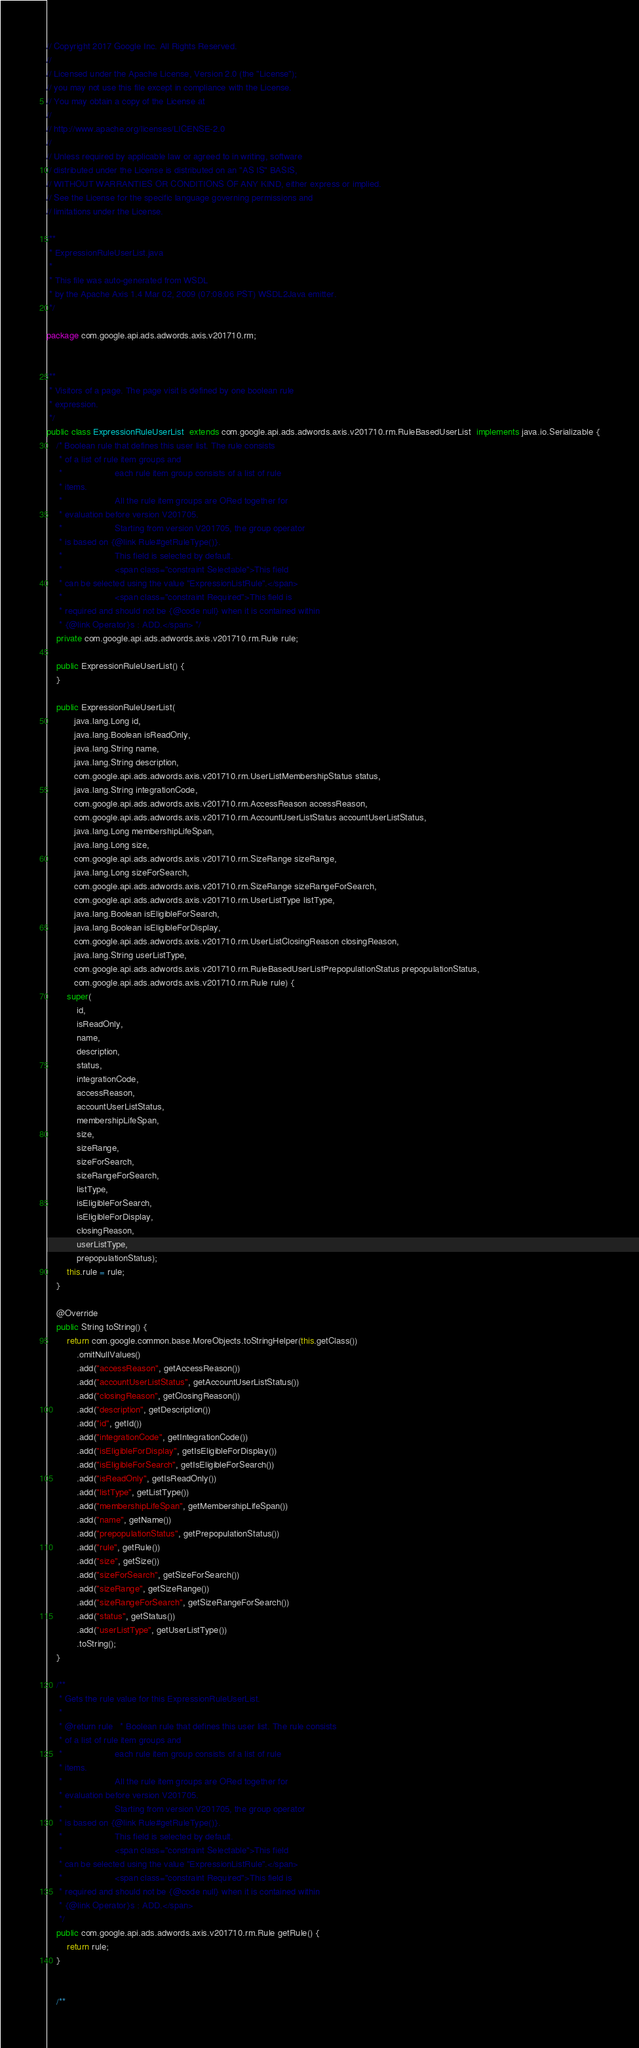<code> <loc_0><loc_0><loc_500><loc_500><_Java_>// Copyright 2017 Google Inc. All Rights Reserved.
//
// Licensed under the Apache License, Version 2.0 (the "License");
// you may not use this file except in compliance with the License.
// You may obtain a copy of the License at
//
// http://www.apache.org/licenses/LICENSE-2.0
//
// Unless required by applicable law or agreed to in writing, software
// distributed under the License is distributed on an "AS IS" BASIS,
// WITHOUT WARRANTIES OR CONDITIONS OF ANY KIND, either express or implied.
// See the License for the specific language governing permissions and
// limitations under the License.

/**
 * ExpressionRuleUserList.java
 *
 * This file was auto-generated from WSDL
 * by the Apache Axis 1.4 Mar 02, 2009 (07:08:06 PST) WSDL2Java emitter.
 */

package com.google.api.ads.adwords.axis.v201710.rm;


/**
 * Visitors of a page. The page visit is defined by one boolean rule
 * expression.
 */
public class ExpressionRuleUserList  extends com.google.api.ads.adwords.axis.v201710.rm.RuleBasedUserList  implements java.io.Serializable {
    /* Boolean rule that defines this user list. The rule consists
     * of a list of rule item groups and
     *                     each rule item group consists of a list of rule
     * items.
     *                     All the rule item groups are ORed together for
     * evaluation before version V201705.
     *                     Starting from version V201705, the group operator
     * is based on {@link Rule#getRuleType()}.
     *                     This field is selected by default.
     *                     <span class="constraint Selectable">This field
     * can be selected using the value "ExpressionListRule".</span>
     *                     <span class="constraint Required">This field is
     * required and should not be {@code null} when it is contained within
     * {@link Operator}s : ADD.</span> */
    private com.google.api.ads.adwords.axis.v201710.rm.Rule rule;

    public ExpressionRuleUserList() {
    }

    public ExpressionRuleUserList(
           java.lang.Long id,
           java.lang.Boolean isReadOnly,
           java.lang.String name,
           java.lang.String description,
           com.google.api.ads.adwords.axis.v201710.rm.UserListMembershipStatus status,
           java.lang.String integrationCode,
           com.google.api.ads.adwords.axis.v201710.rm.AccessReason accessReason,
           com.google.api.ads.adwords.axis.v201710.rm.AccountUserListStatus accountUserListStatus,
           java.lang.Long membershipLifeSpan,
           java.lang.Long size,
           com.google.api.ads.adwords.axis.v201710.rm.SizeRange sizeRange,
           java.lang.Long sizeForSearch,
           com.google.api.ads.adwords.axis.v201710.rm.SizeRange sizeRangeForSearch,
           com.google.api.ads.adwords.axis.v201710.rm.UserListType listType,
           java.lang.Boolean isEligibleForSearch,
           java.lang.Boolean isEligibleForDisplay,
           com.google.api.ads.adwords.axis.v201710.rm.UserListClosingReason closingReason,
           java.lang.String userListType,
           com.google.api.ads.adwords.axis.v201710.rm.RuleBasedUserListPrepopulationStatus prepopulationStatus,
           com.google.api.ads.adwords.axis.v201710.rm.Rule rule) {
        super(
            id,
            isReadOnly,
            name,
            description,
            status,
            integrationCode,
            accessReason,
            accountUserListStatus,
            membershipLifeSpan,
            size,
            sizeRange,
            sizeForSearch,
            sizeRangeForSearch,
            listType,
            isEligibleForSearch,
            isEligibleForDisplay,
            closingReason,
            userListType,
            prepopulationStatus);
        this.rule = rule;
    }

    @Override
    public String toString() {
        return com.google.common.base.MoreObjects.toStringHelper(this.getClass())
            .omitNullValues()
            .add("accessReason", getAccessReason())
            .add("accountUserListStatus", getAccountUserListStatus())
            .add("closingReason", getClosingReason())
            .add("description", getDescription())
            .add("id", getId())
            .add("integrationCode", getIntegrationCode())
            .add("isEligibleForDisplay", getIsEligibleForDisplay())
            .add("isEligibleForSearch", getIsEligibleForSearch())
            .add("isReadOnly", getIsReadOnly())
            .add("listType", getListType())
            .add("membershipLifeSpan", getMembershipLifeSpan())
            .add("name", getName())
            .add("prepopulationStatus", getPrepopulationStatus())
            .add("rule", getRule())
            .add("size", getSize())
            .add("sizeForSearch", getSizeForSearch())
            .add("sizeRange", getSizeRange())
            .add("sizeRangeForSearch", getSizeRangeForSearch())
            .add("status", getStatus())
            .add("userListType", getUserListType())
            .toString();
    }

    /**
     * Gets the rule value for this ExpressionRuleUserList.
     * 
     * @return rule   * Boolean rule that defines this user list. The rule consists
     * of a list of rule item groups and
     *                     each rule item group consists of a list of rule
     * items.
     *                     All the rule item groups are ORed together for
     * evaluation before version V201705.
     *                     Starting from version V201705, the group operator
     * is based on {@link Rule#getRuleType()}.
     *                     This field is selected by default.
     *                     <span class="constraint Selectable">This field
     * can be selected using the value "ExpressionListRule".</span>
     *                     <span class="constraint Required">This field is
     * required and should not be {@code null} when it is contained within
     * {@link Operator}s : ADD.</span>
     */
    public com.google.api.ads.adwords.axis.v201710.rm.Rule getRule() {
        return rule;
    }


    /**</code> 